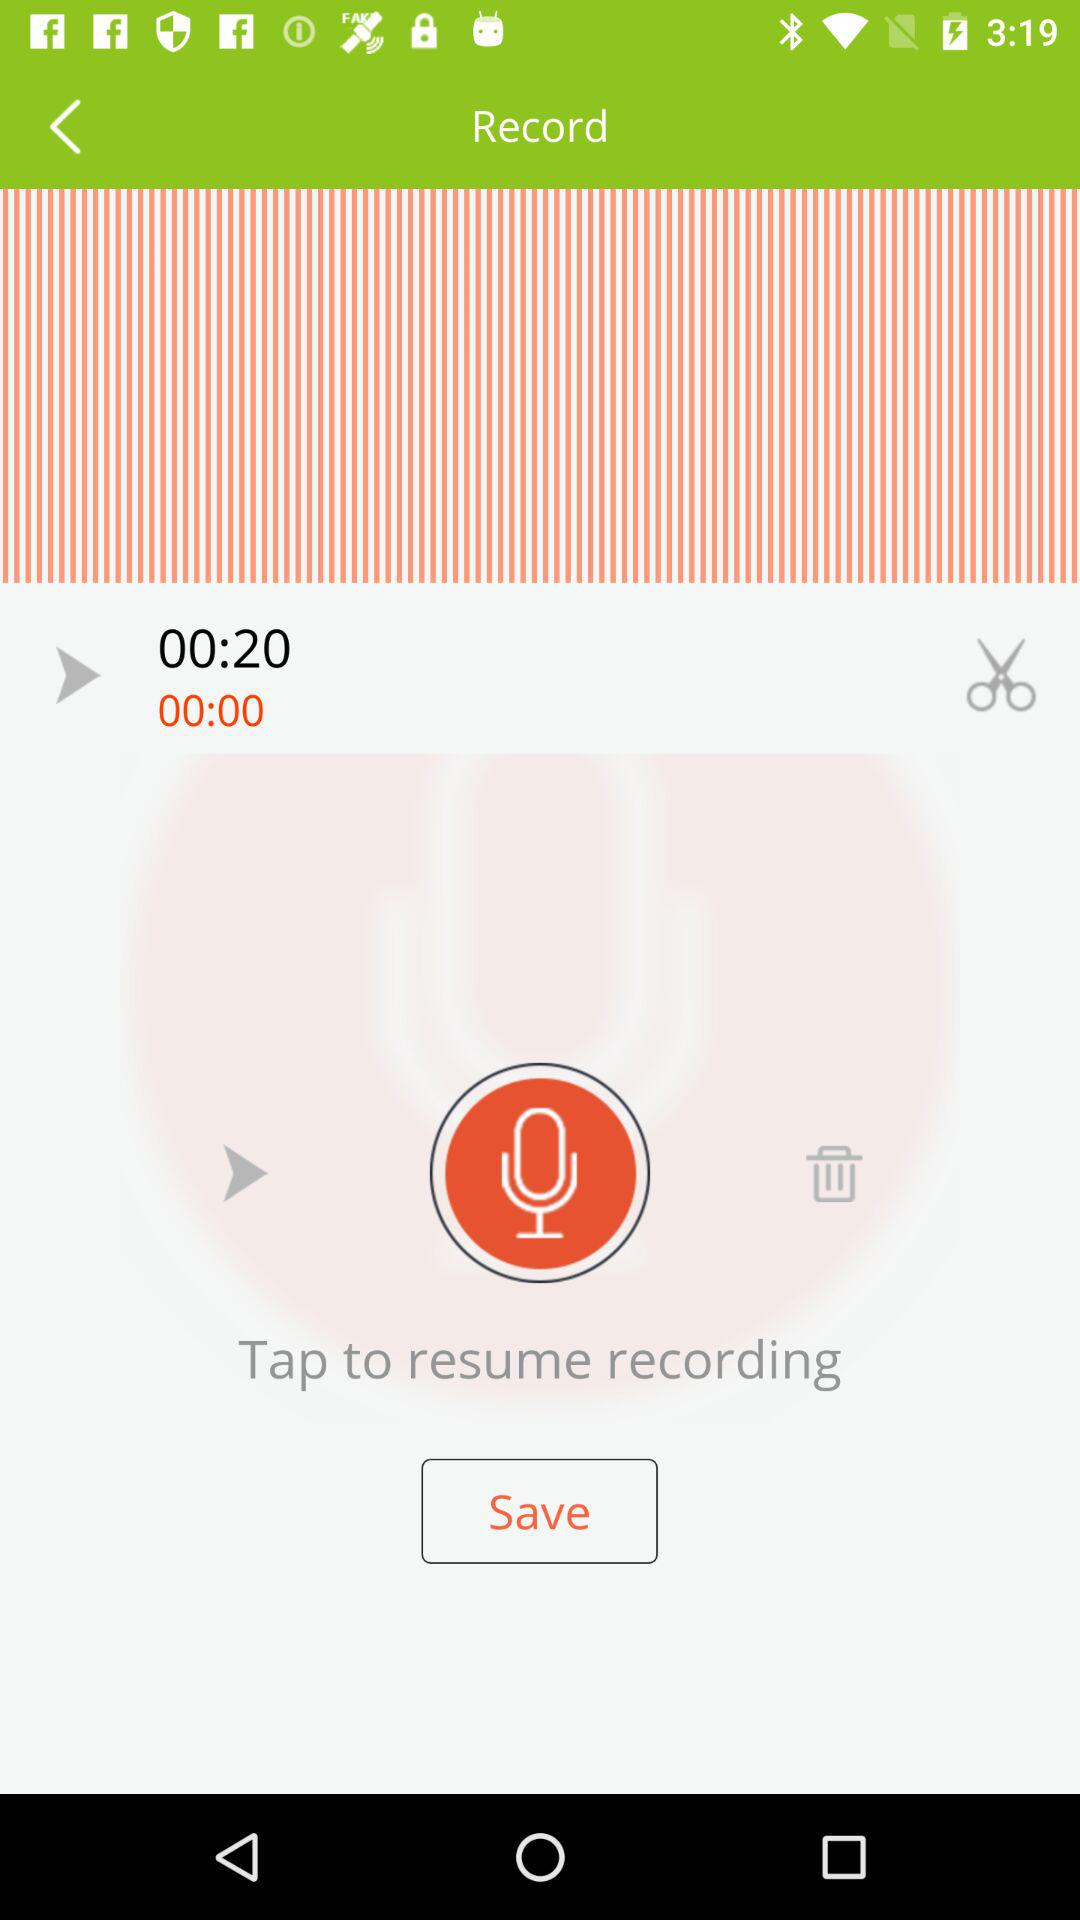How many seconds is the current recording?
Answer the question using a single word or phrase. 20 